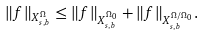<formula> <loc_0><loc_0><loc_500><loc_500>\| f \| _ { X _ { s , b } ^ { \Omega } } \leq \| f \| _ { X _ { s , b } ^ { \Omega _ { 0 } } } + \| f \| _ { X _ { s , b } ^ { \Omega / \Omega _ { 0 } } } .</formula> 